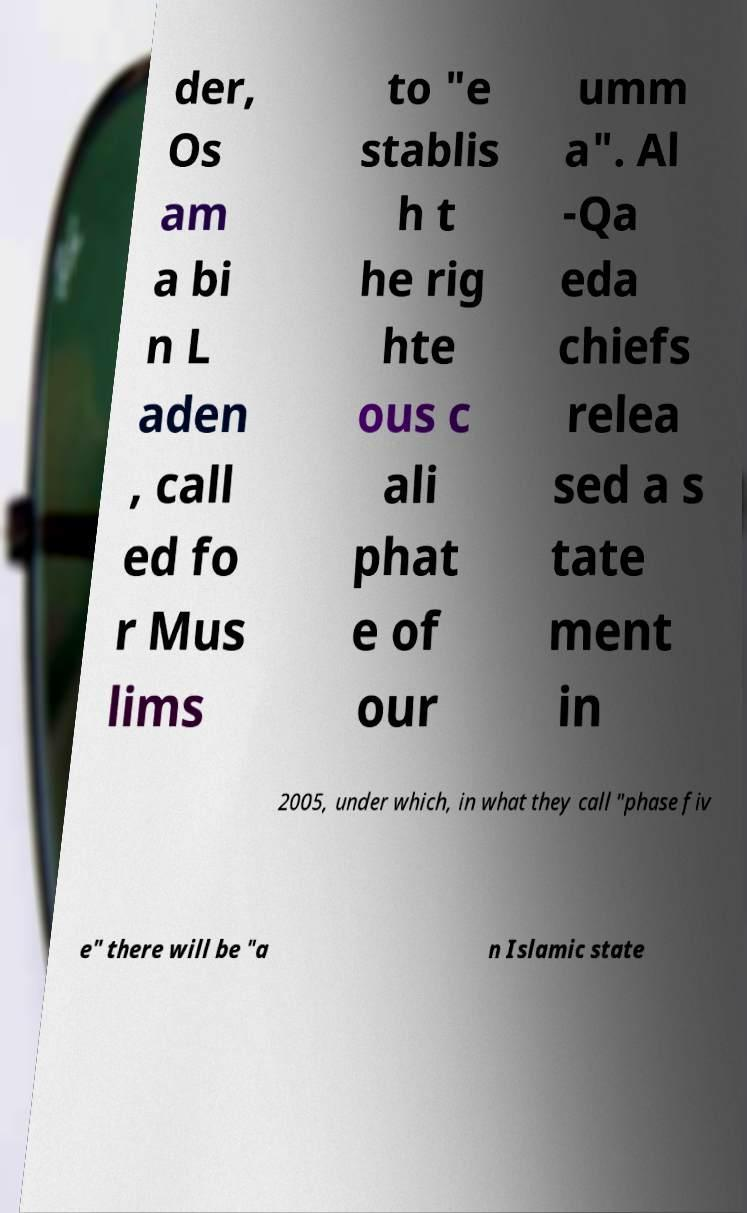Can you accurately transcribe the text from the provided image for me? der, Os am a bi n L aden , call ed fo r Mus lims to "e stablis h t he rig hte ous c ali phat e of our umm a". Al -Qa eda chiefs relea sed a s tate ment in 2005, under which, in what they call "phase fiv e" there will be "a n Islamic state 